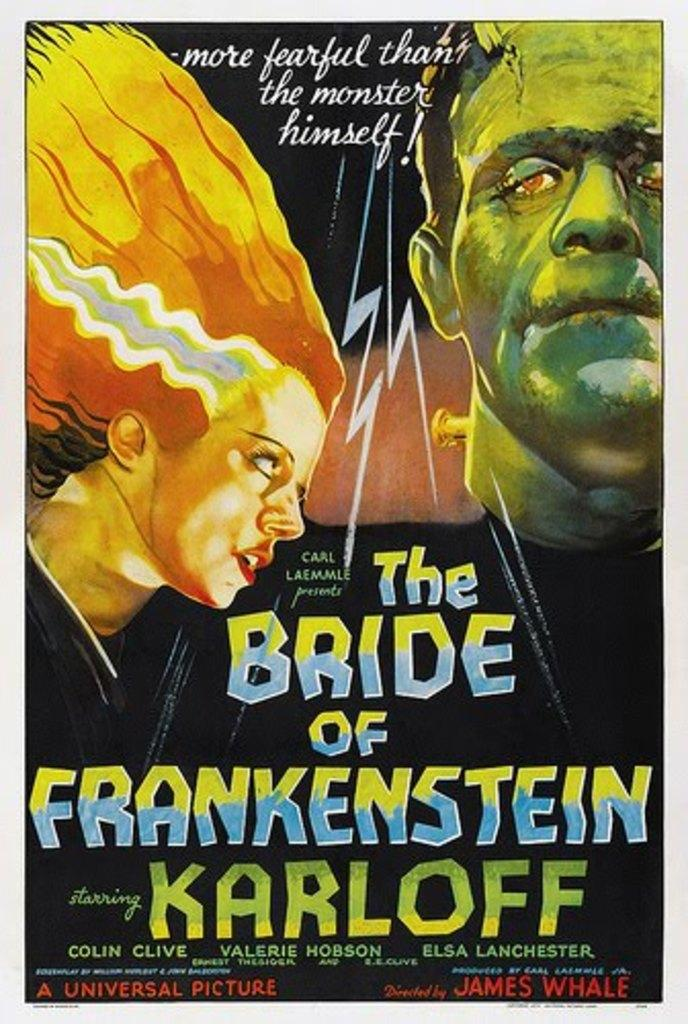<image>
Render a clear and concise summary of the photo. The Bride of Frankenstein book cover by Karloff. 